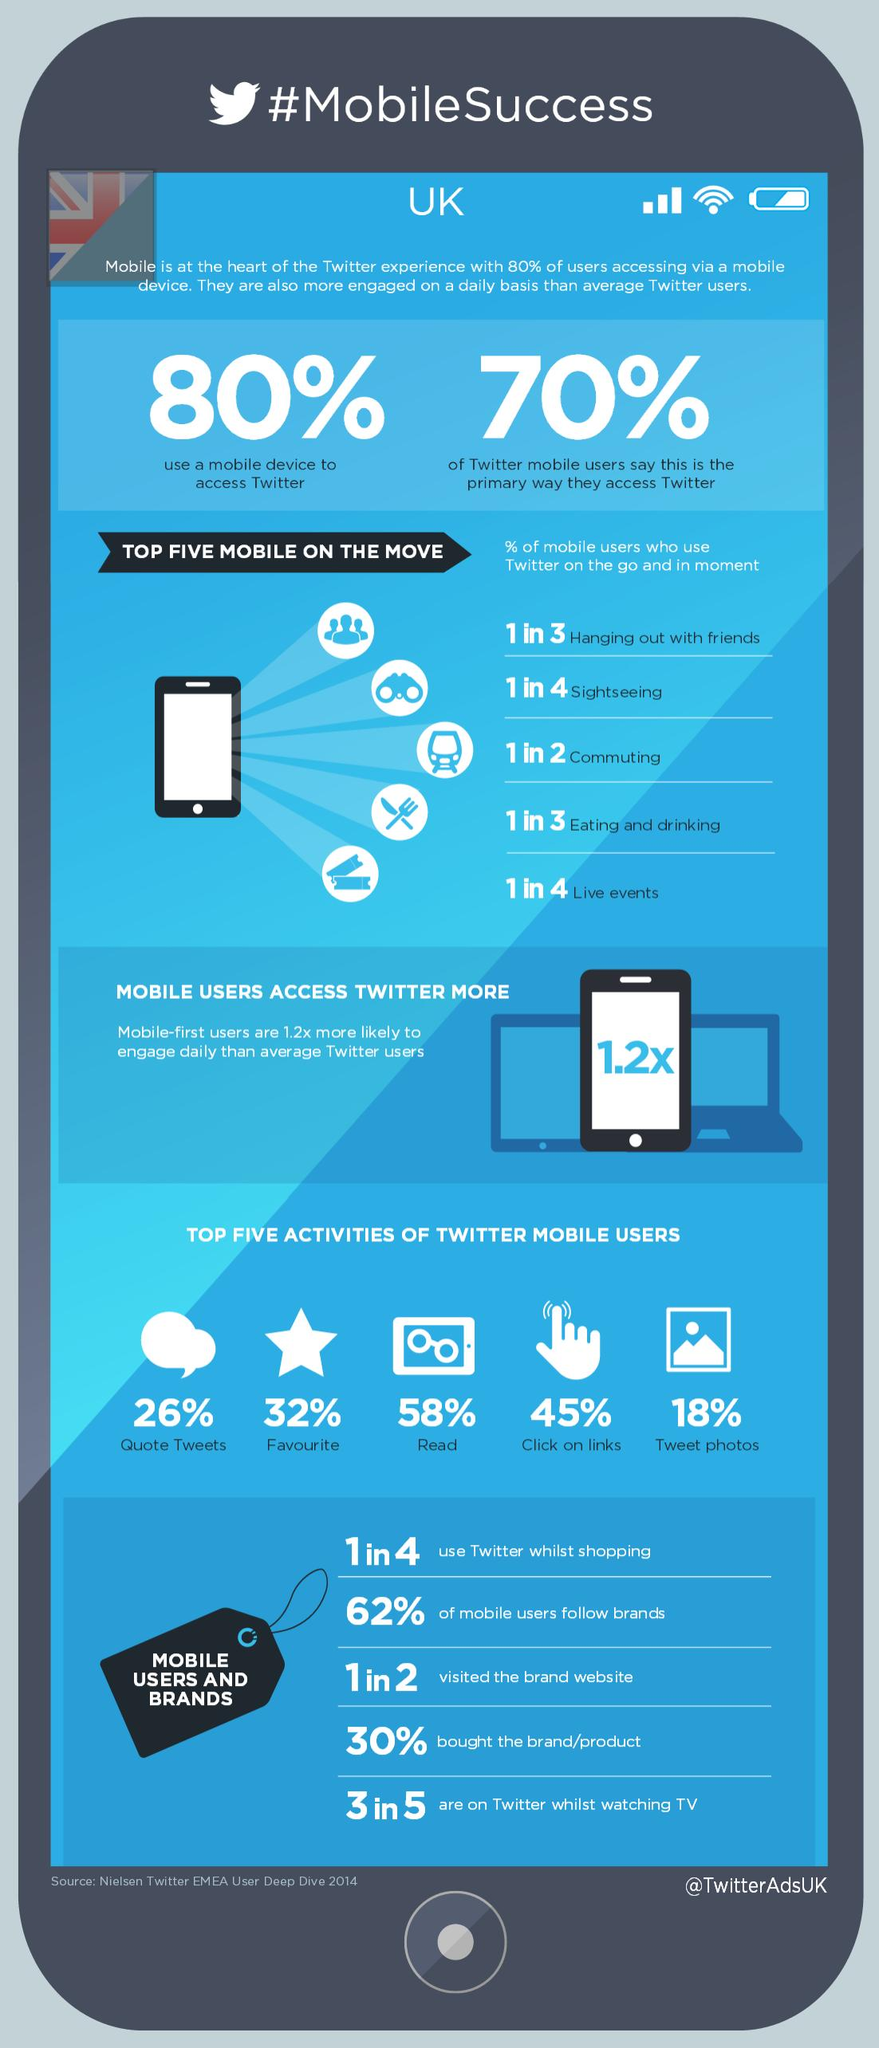Point out several critical features in this image. According to the data, approximately 38% of mobile users do not follow brands on social media platforms. The Twitter handle given is @TwitterAdsUK. The activity most commonly performed by Twitter mobile users is reading. 